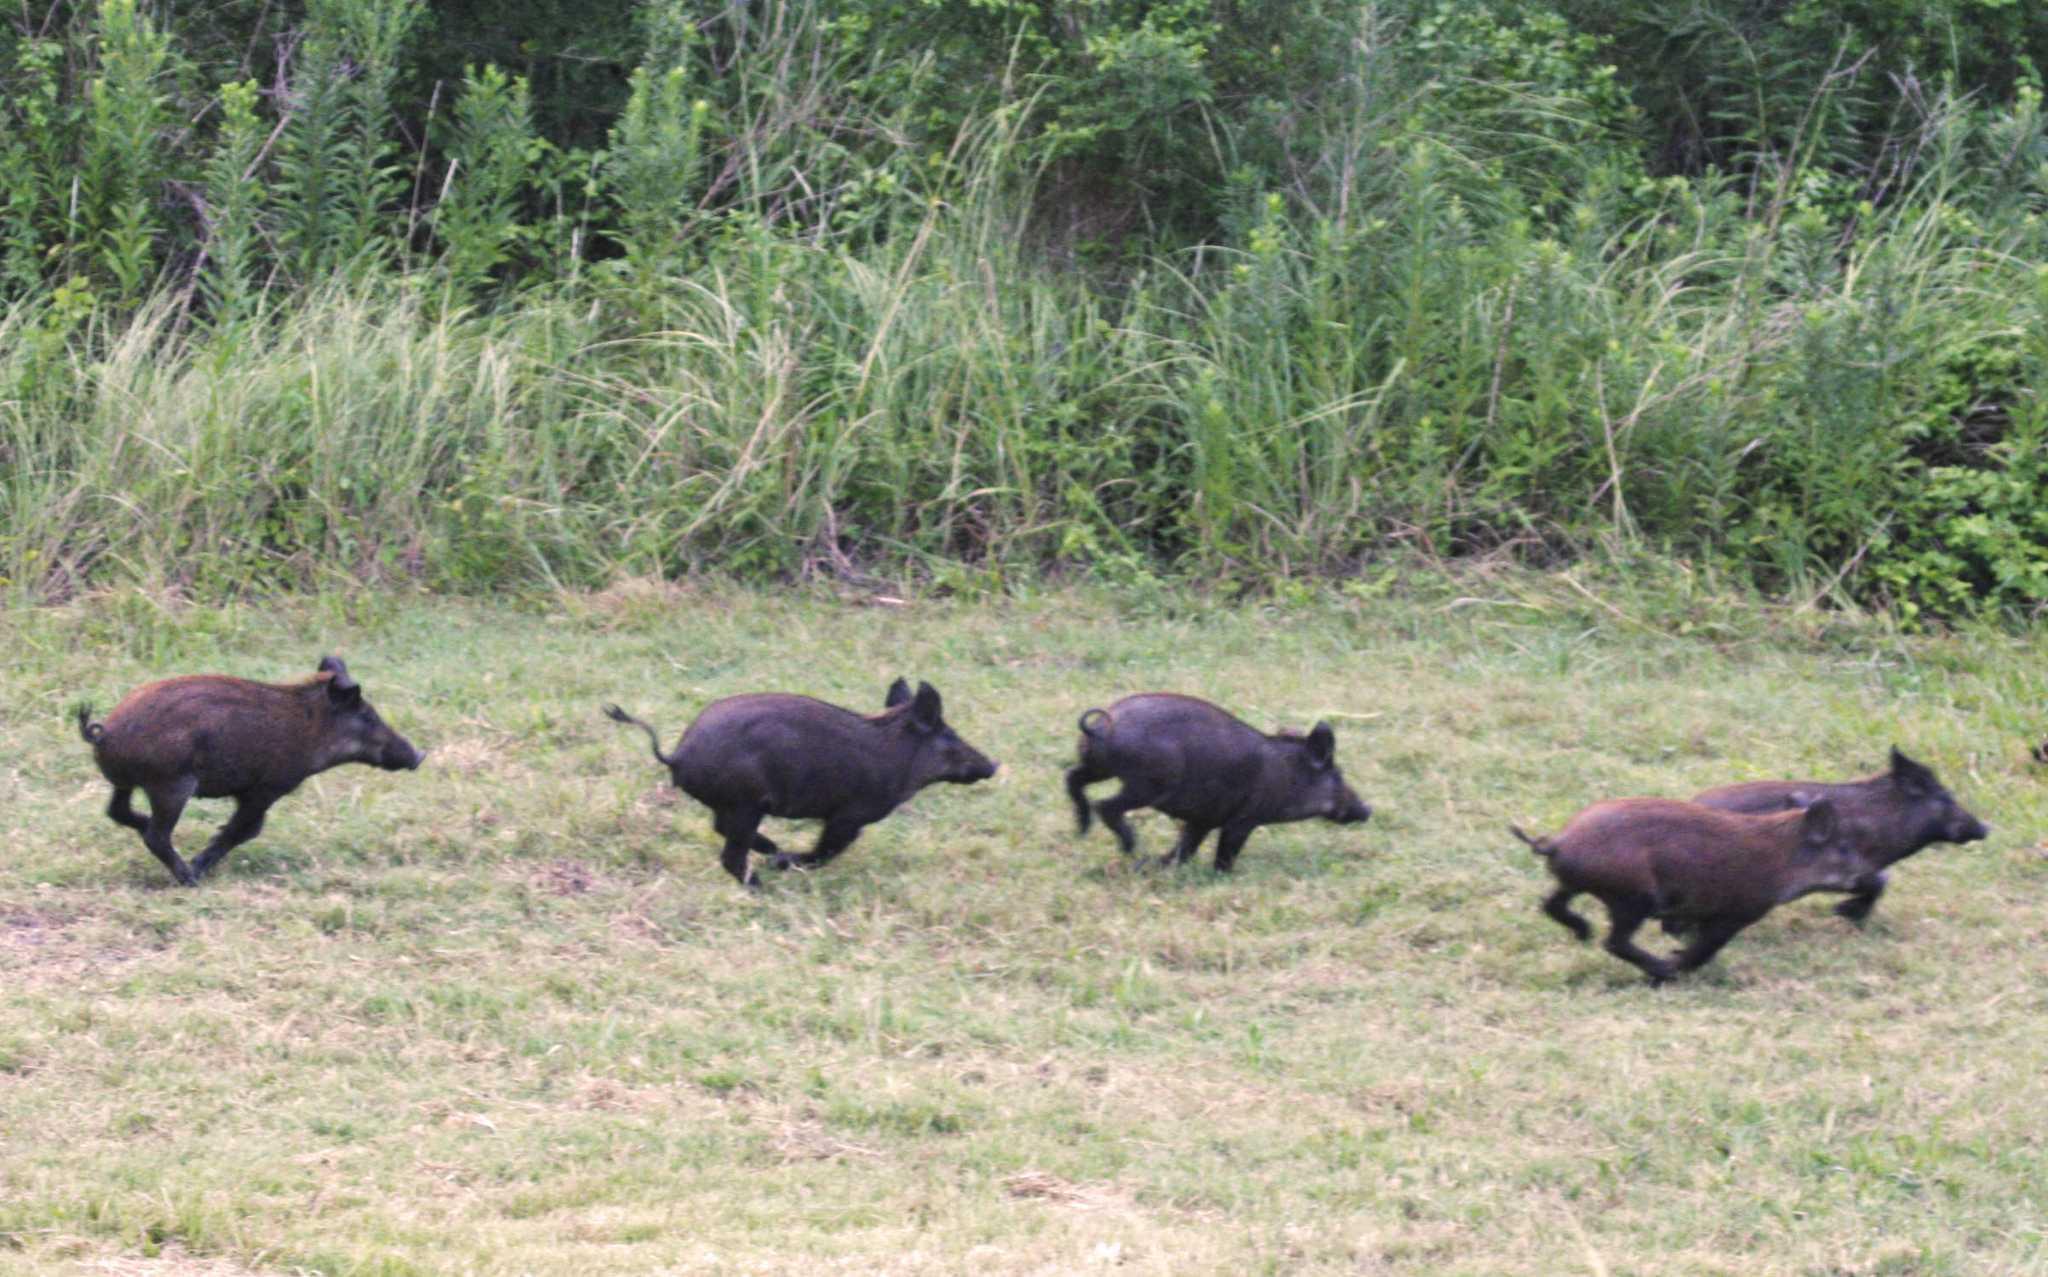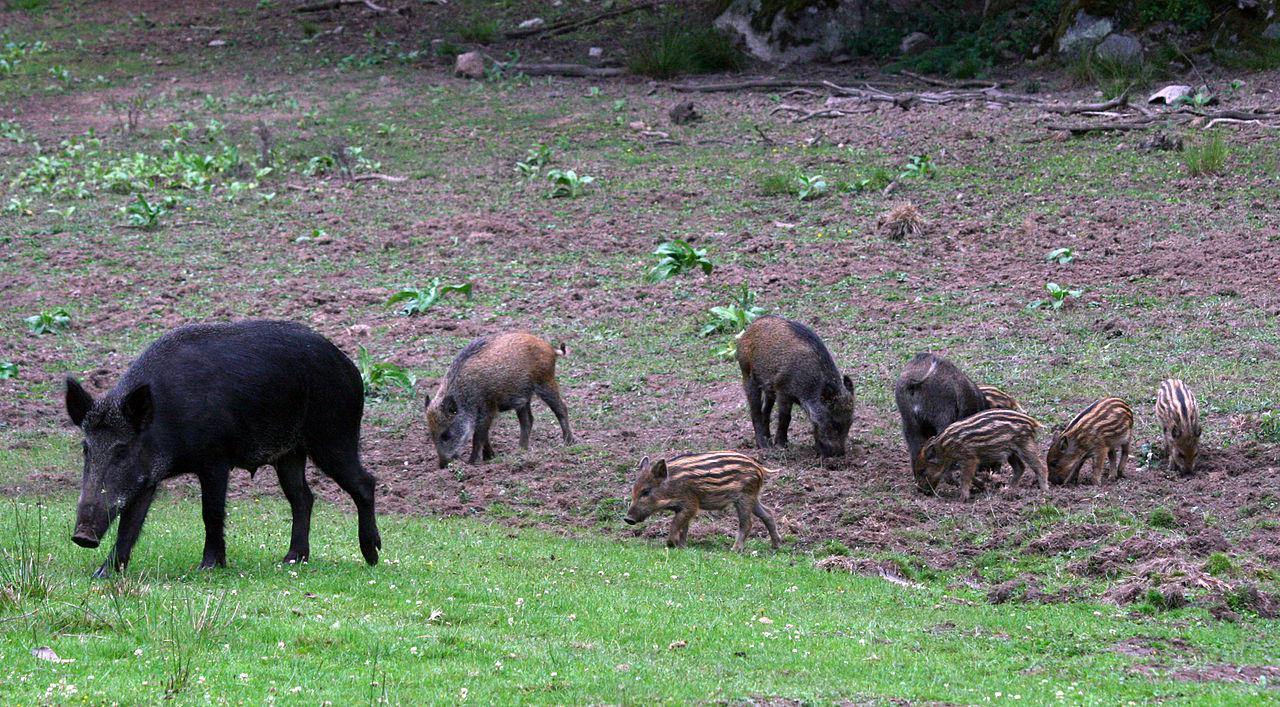The first image is the image on the left, the second image is the image on the right. Examine the images to the left and right. Is the description "there is a person crouched down behind a dead boar on brown grass" accurate? Answer yes or no. No. The first image is the image on the left, the second image is the image on the right. For the images shown, is this caption "In at least one image there is a person kneeing over a dead boar with its mouth hanging open." true? Answer yes or no. No. 